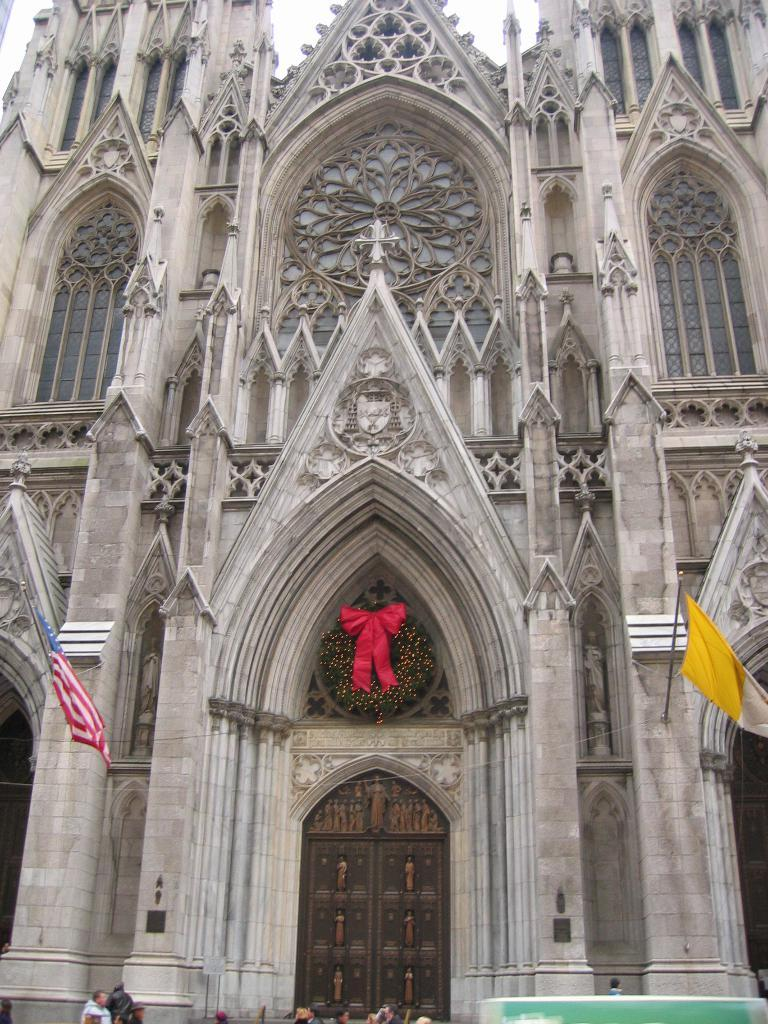What is the main structure in the foreground of the image? There is a church in the foreground of the image. What can be seen on either side of the church entrance? There are two flags on either side of the church entrance. Are there any people visible in the image? Yes, there are persons visible in the image. What else can be seen in the image besides the church and people? There is a vehicle in the image. What type of pie is being served at the church in the image? There is no pie visible in the image, nor is there any indication that food is being served. 